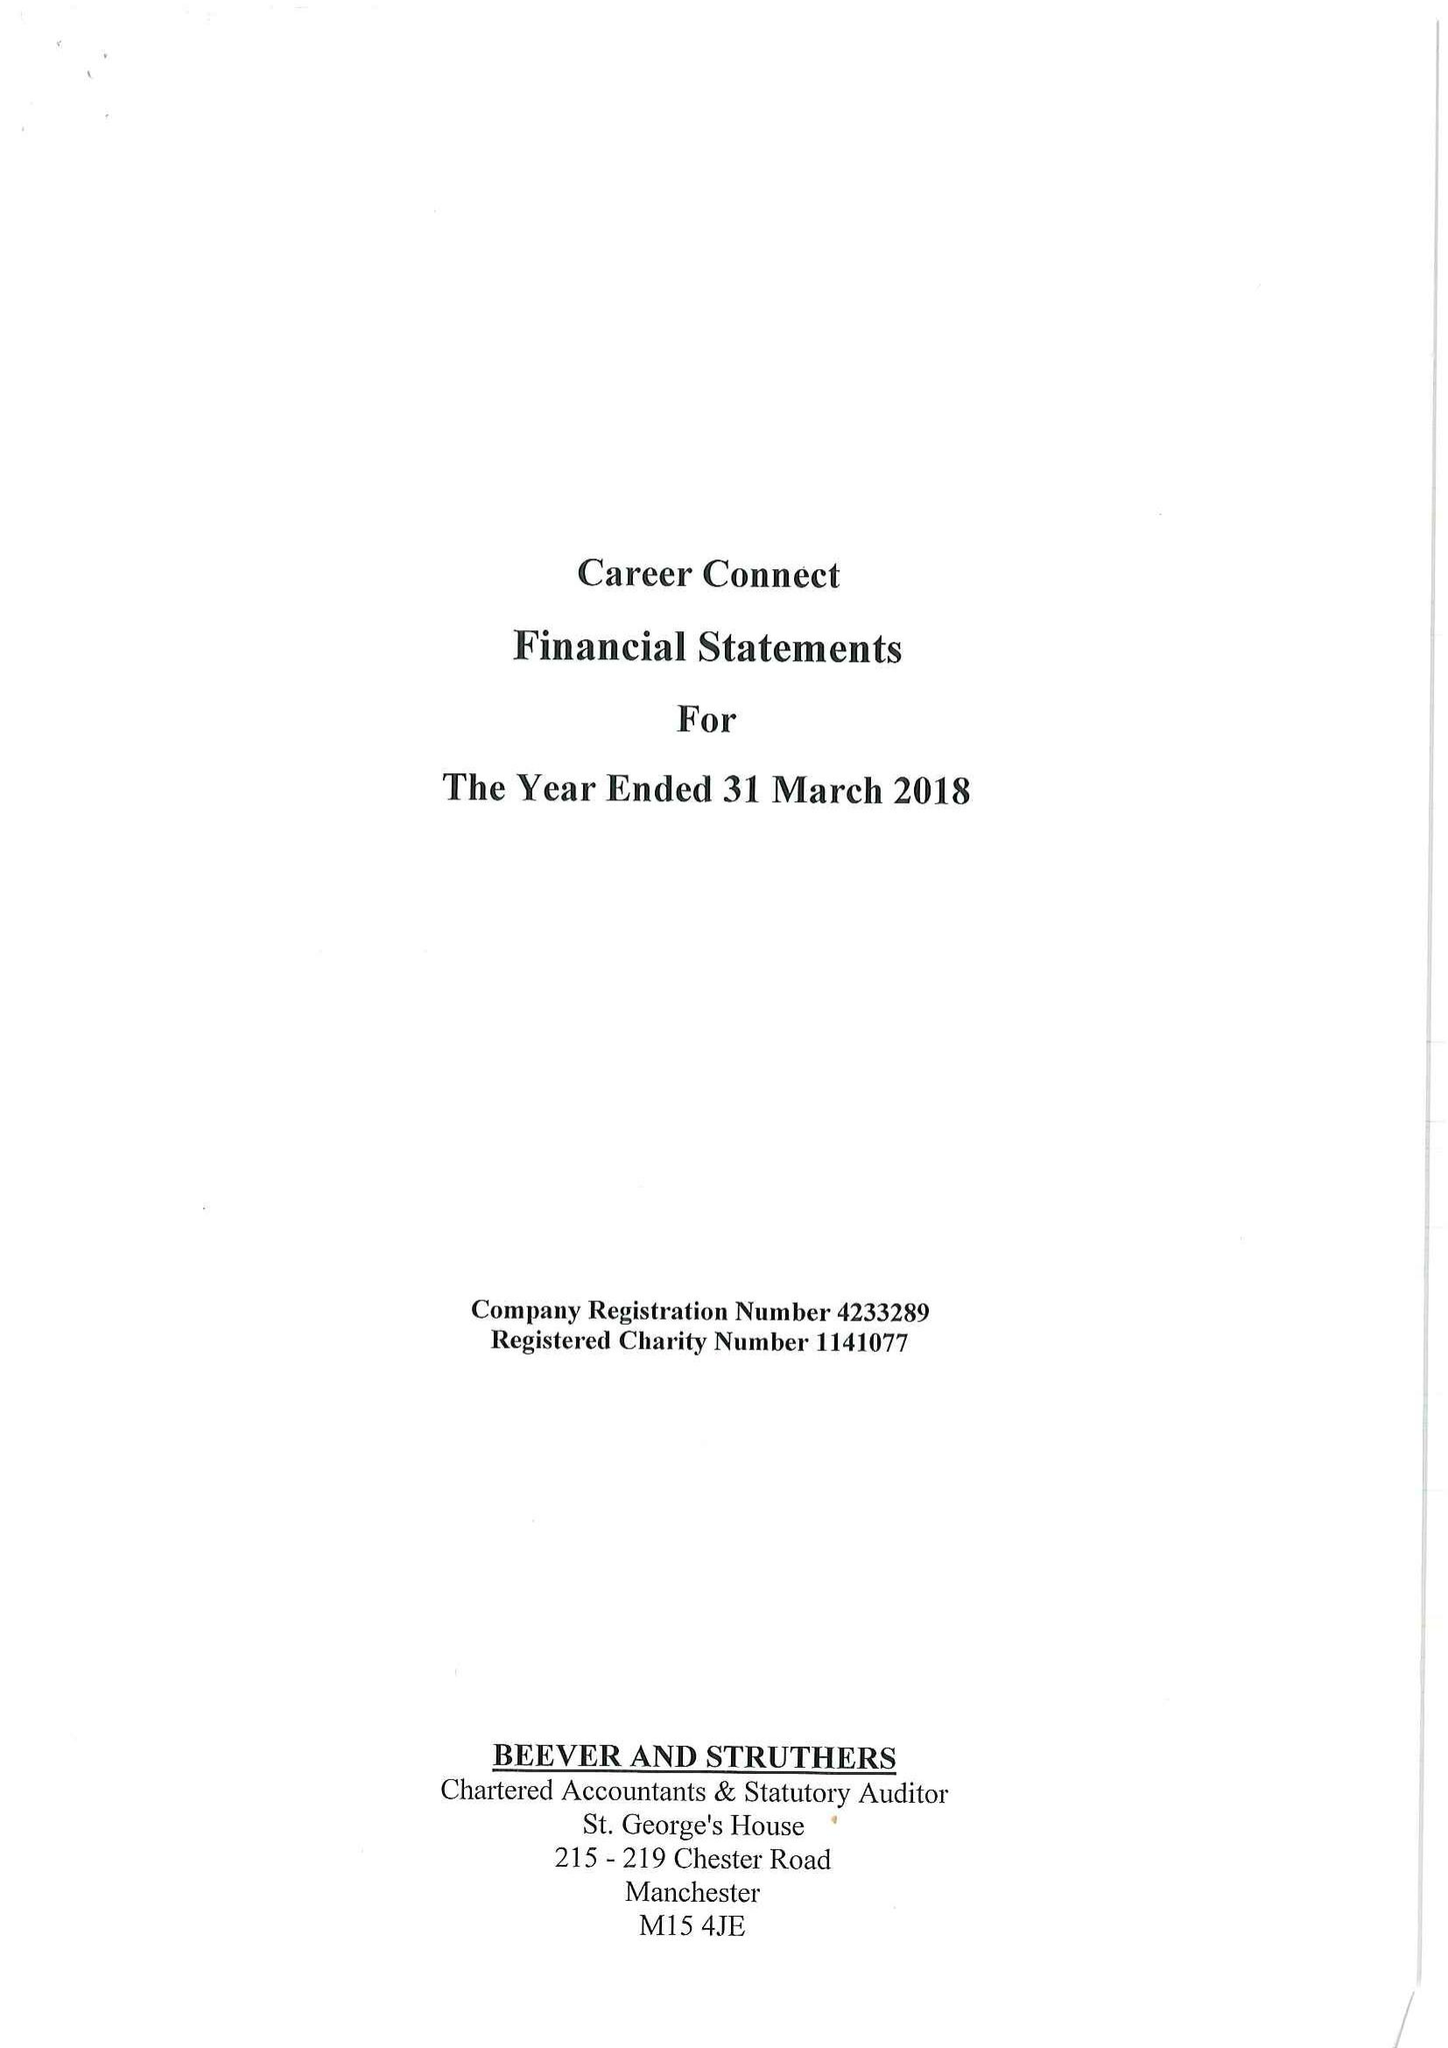What is the value for the charity_number?
Answer the question using a single word or phrase. 1141077 